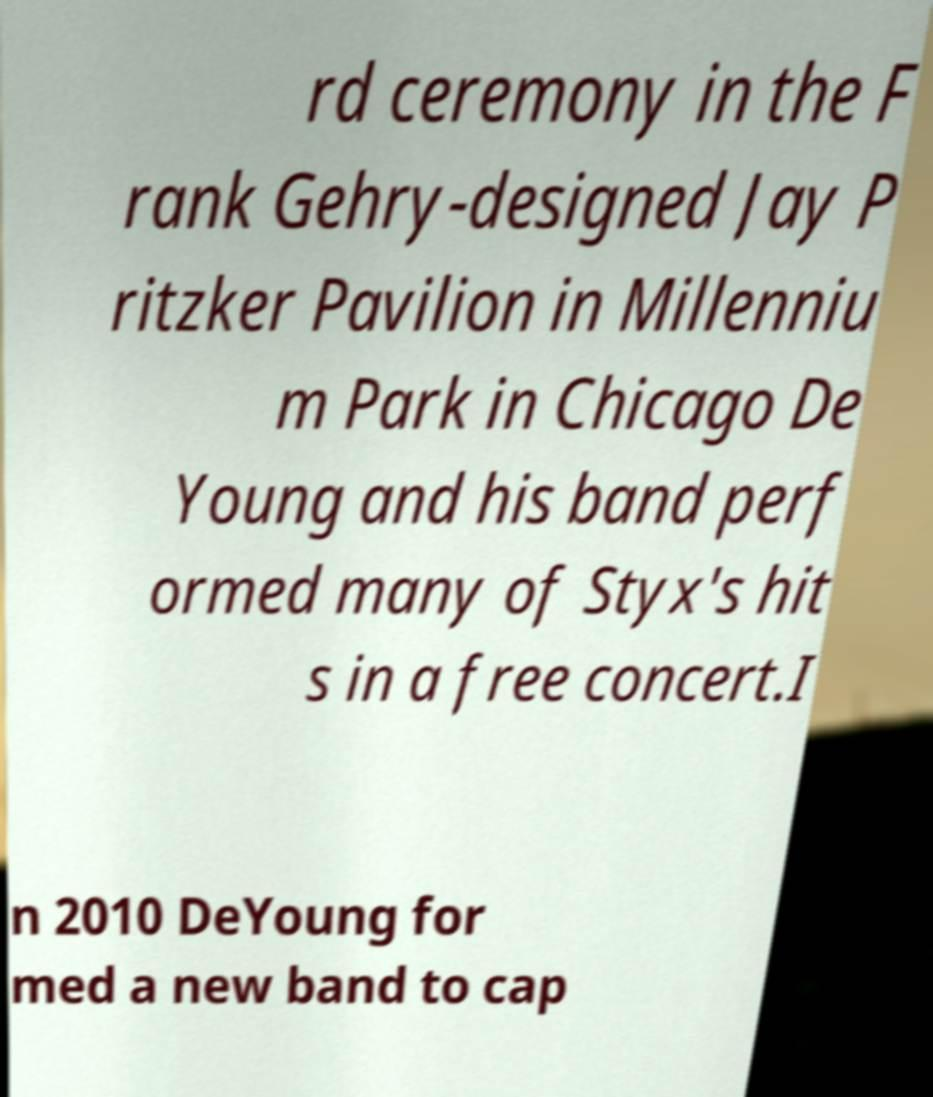Please identify and transcribe the text found in this image. rd ceremony in the F rank Gehry-designed Jay P ritzker Pavilion in Millenniu m Park in Chicago De Young and his band perf ormed many of Styx's hit s in a free concert.I n 2010 DeYoung for med a new band to cap 